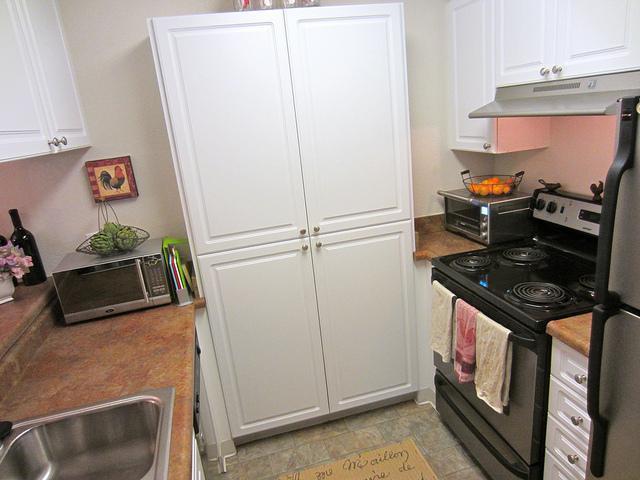How many ovens can you see?
Give a very brief answer. 3. How many birds are on the branch?
Give a very brief answer. 0. 